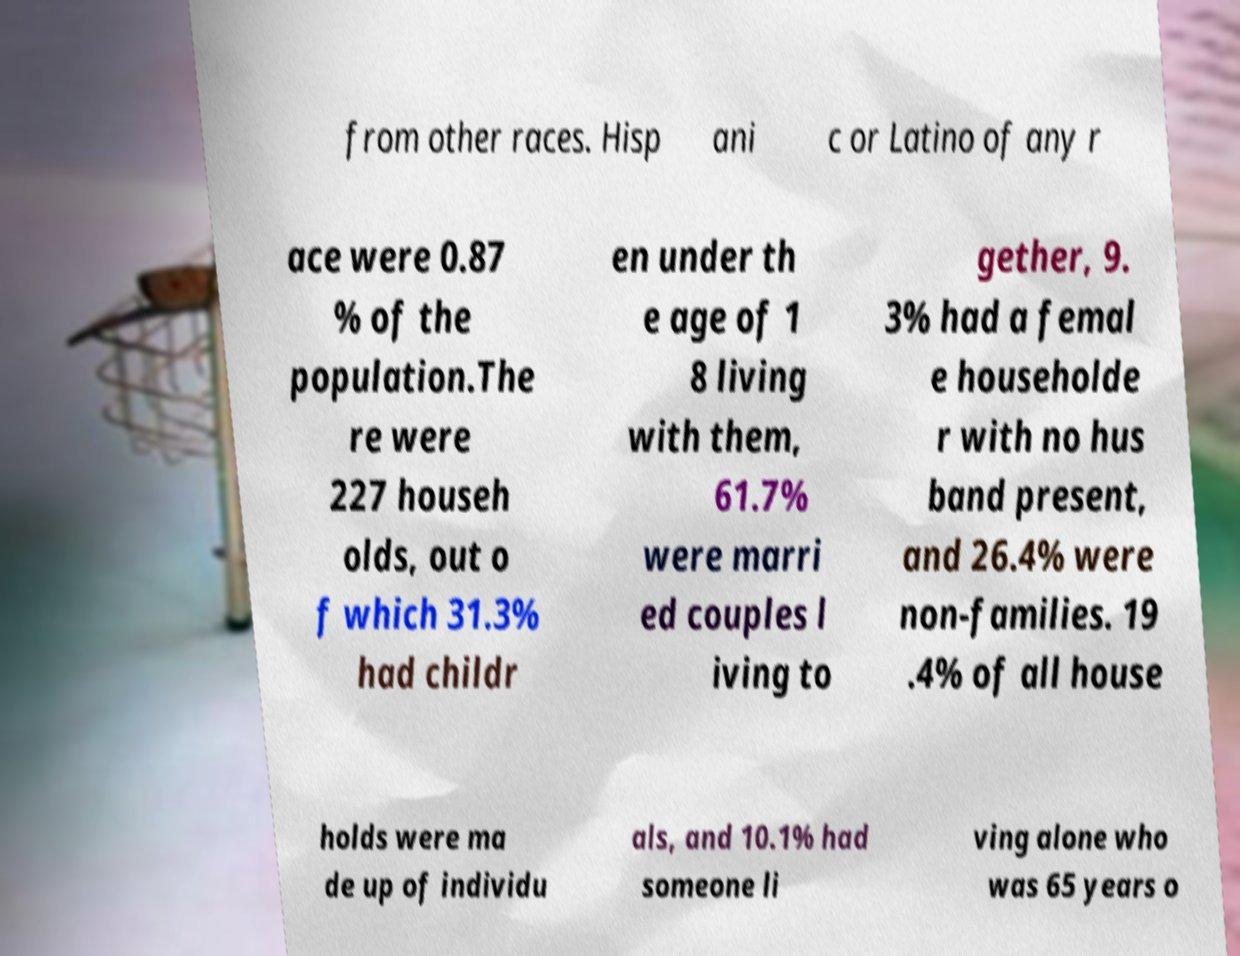What messages or text are displayed in this image? I need them in a readable, typed format. from other races. Hisp ani c or Latino of any r ace were 0.87 % of the population.The re were 227 househ olds, out o f which 31.3% had childr en under th e age of 1 8 living with them, 61.7% were marri ed couples l iving to gether, 9. 3% had a femal e householde r with no hus band present, and 26.4% were non-families. 19 .4% of all house holds were ma de up of individu als, and 10.1% had someone li ving alone who was 65 years o 